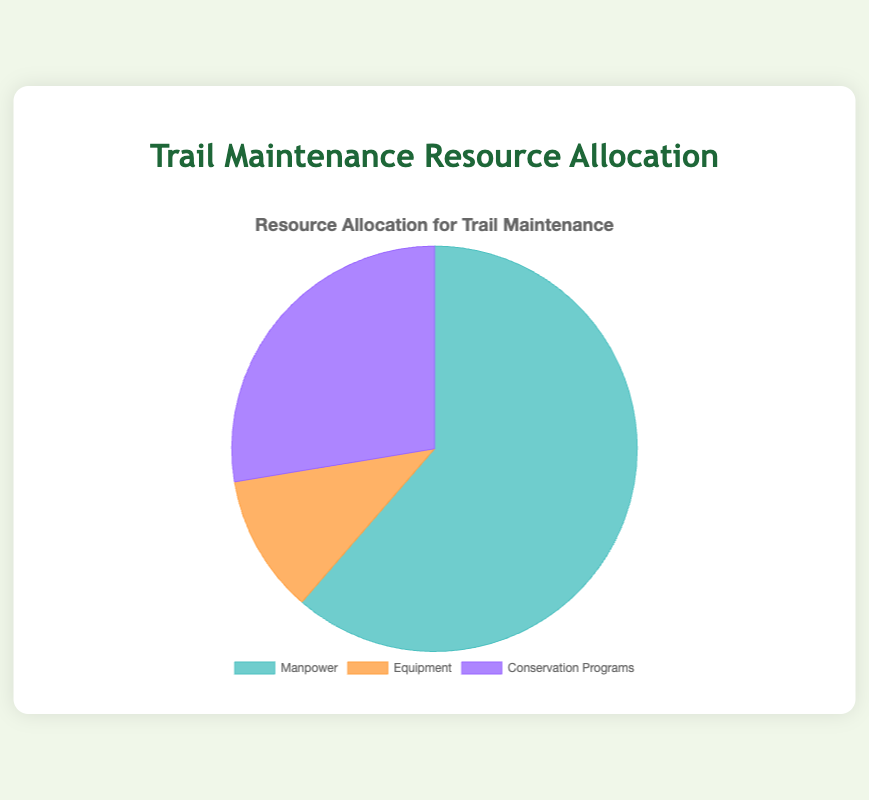What are the three categories shown in the pie chart? The pie chart displays three categories of resource allocation for trail maintenance. They are portrayed by different segments.
Answer: Manpower, Equipment, Conservation Programs Which category has the largest allocation? The segment with the largest slice represents the category with the highest allocation. Looking at the size of each segment, 'Manpower' has the largest allocation.
Answer: Manpower Which category has the smallest allocation? By looking at the segment sizes, the category with the smallest segment area indicates the smallest allocation. 'Equipment' has the smallest allocation.
Answer: Equipment What is the difference in allocation between Manpower and Equipment? Calculate the difference between the allocation of 'Manpower' and 'Equipment' by subtracting the value of 'Equipment' (18) from 'Manpower' (100).
Answer: 82 What percentage of the total allocation is dedicated to Conservation Programs? To find the percentage, divide the allocation of 'Conservation Programs' (45) by the total allocation (100 + 18 + 45 = 163) and then multiply by 100.
Answer: 27.6% Is the allocation for Conservation Programs greater than Equipment but less than Manpower? Compare the allocation values: Conservation Programs has 45, Equipment has 18, and Manpower has 100. Since 18 < 45 < 100, the statement is true.
Answer: Yes What is the combined allocation for Conservation Programs and Equipment? Add the allocations for 'Conservation Programs' (45) and 'Equipment' (18) together.
Answer: 63 How many more units are allocated to Manpower compared to Conservation Programs? Subtract the allocation of 'Conservation Programs' (45) from 'Manpower' (100).
Answer: 55 Which category's allocation is shown in green? By looking at the segment colors, determine which category is represented by green.
Answer: Manpower 